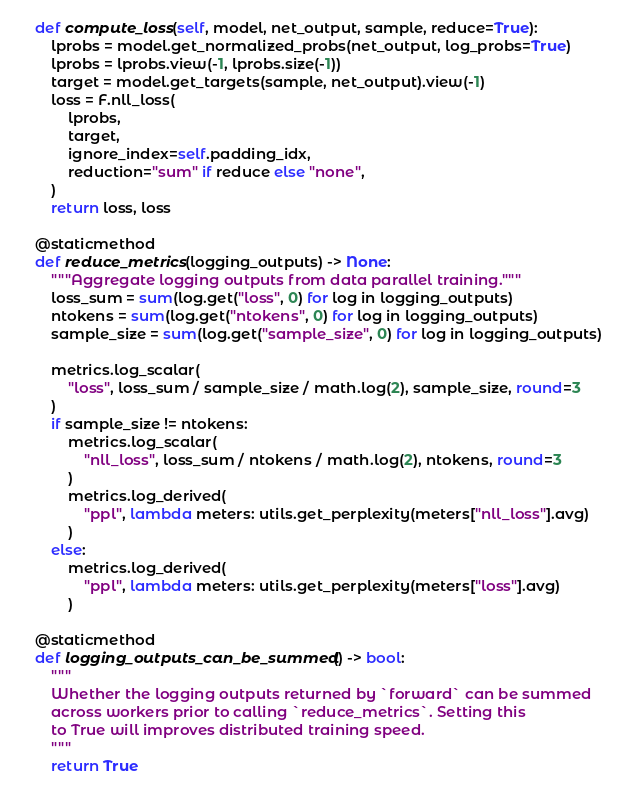<code> <loc_0><loc_0><loc_500><loc_500><_Python_>
    def compute_loss(self, model, net_output, sample, reduce=True):
        lprobs = model.get_normalized_probs(net_output, log_probs=True)
        lprobs = lprobs.view(-1, lprobs.size(-1))
        target = model.get_targets(sample, net_output).view(-1)
        loss = F.nll_loss(
            lprobs,
            target,
            ignore_index=self.padding_idx,
            reduction="sum" if reduce else "none",
        )
        return loss, loss

    @staticmethod
    def reduce_metrics(logging_outputs) -> None:
        """Aggregate logging outputs from data parallel training."""
        loss_sum = sum(log.get("loss", 0) for log in logging_outputs)
        ntokens = sum(log.get("ntokens", 0) for log in logging_outputs)
        sample_size = sum(log.get("sample_size", 0) for log in logging_outputs)

        metrics.log_scalar(
            "loss", loss_sum / sample_size / math.log(2), sample_size, round=3
        )
        if sample_size != ntokens:
            metrics.log_scalar(
                "nll_loss", loss_sum / ntokens / math.log(2), ntokens, round=3
            )
            metrics.log_derived(
                "ppl", lambda meters: utils.get_perplexity(meters["nll_loss"].avg)
            )
        else:
            metrics.log_derived(
                "ppl", lambda meters: utils.get_perplexity(meters["loss"].avg)
            )

    @staticmethod
    def logging_outputs_can_be_summed() -> bool:
        """
        Whether the logging outputs returned by `forward` can be summed
        across workers prior to calling `reduce_metrics`. Setting this
        to True will improves distributed training speed.
        """
        return True
</code> 